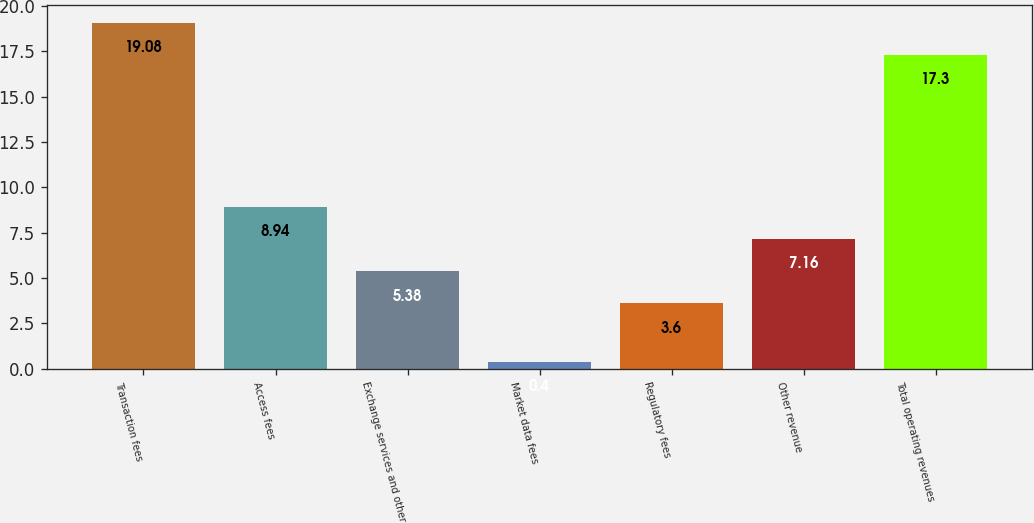<chart> <loc_0><loc_0><loc_500><loc_500><bar_chart><fcel>Transaction fees<fcel>Access fees<fcel>Exchange services and other<fcel>Market data fees<fcel>Regulatory fees<fcel>Other revenue<fcel>Total operating revenues<nl><fcel>19.08<fcel>8.94<fcel>5.38<fcel>0.4<fcel>3.6<fcel>7.16<fcel>17.3<nl></chart> 